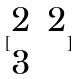<formula> <loc_0><loc_0><loc_500><loc_500>[ \begin{matrix} 2 & 2 \\ 3 \end{matrix} ]</formula> 